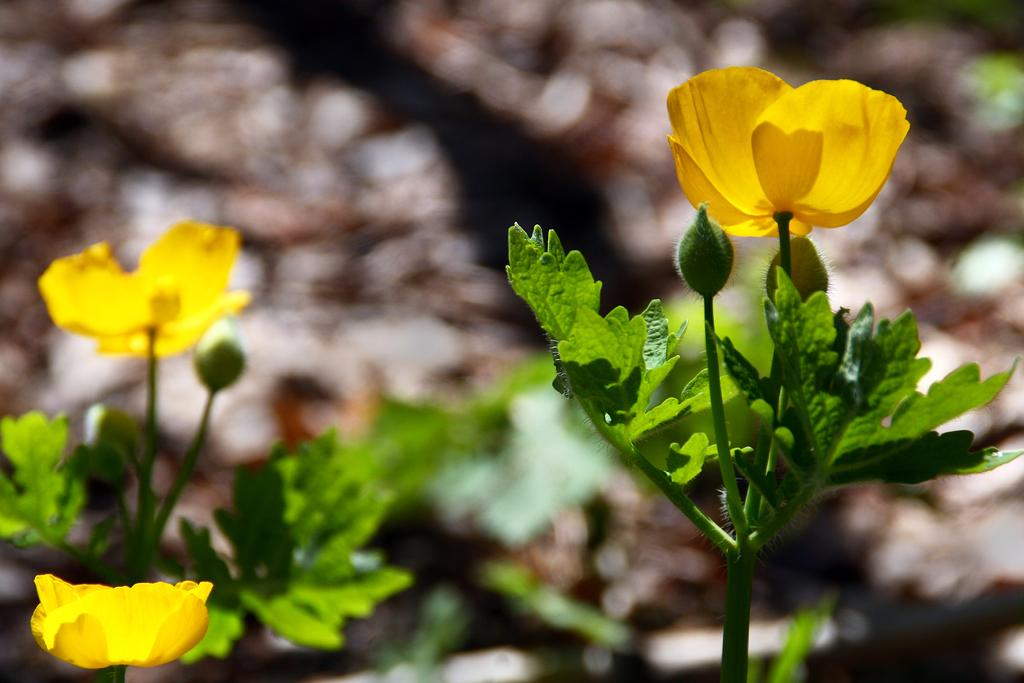What type of plants can be seen in the image? There are flowers in the image. What stage of growth are the plants in? There are buds on the plants in the image. Can you describe the background of the image? The background of the image is blurry. What type of hook is visible in the image? There is no hook present in the image. What kind of art can be seen in the background of the image? The background of the image is blurry, and no art is visible. 